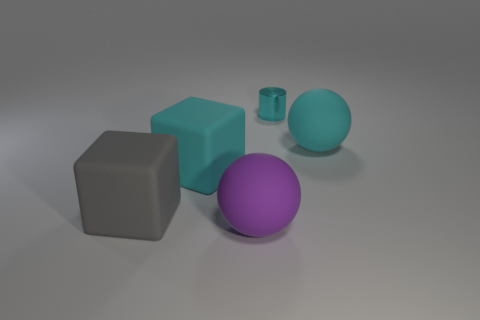Add 4 cyan rubber spheres. How many objects exist? 9 Subtract all yellow balls. How many yellow cylinders are left? 0 Subtract 0 blue balls. How many objects are left? 5 Subtract all spheres. How many objects are left? 3 Subtract 1 cubes. How many cubes are left? 1 Subtract all brown blocks. Subtract all gray cylinders. How many blocks are left? 2 Subtract all rubber objects. Subtract all large cyan matte balls. How many objects are left? 0 Add 1 small objects. How many small objects are left? 2 Add 1 large spheres. How many large spheres exist? 3 